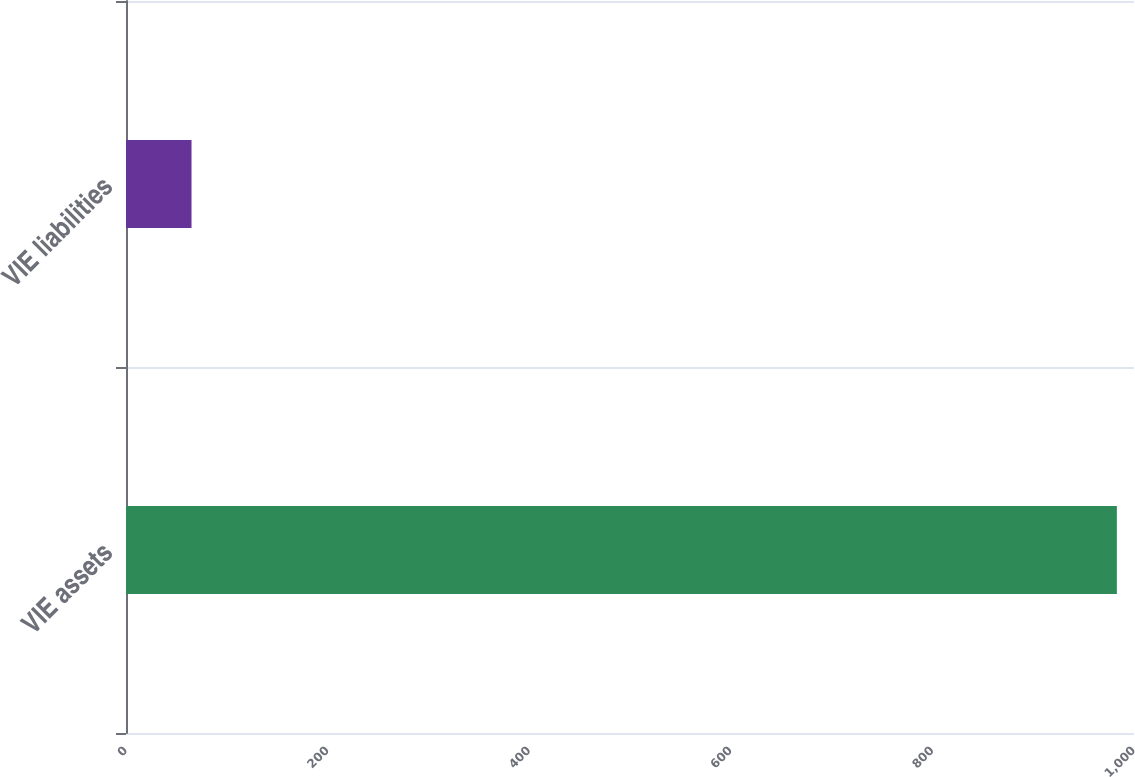Convert chart. <chart><loc_0><loc_0><loc_500><loc_500><bar_chart><fcel>VIE assets<fcel>VIE liabilities<nl><fcel>983<fcel>65<nl></chart> 